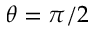<formula> <loc_0><loc_0><loc_500><loc_500>\theta = \pi / 2</formula> 